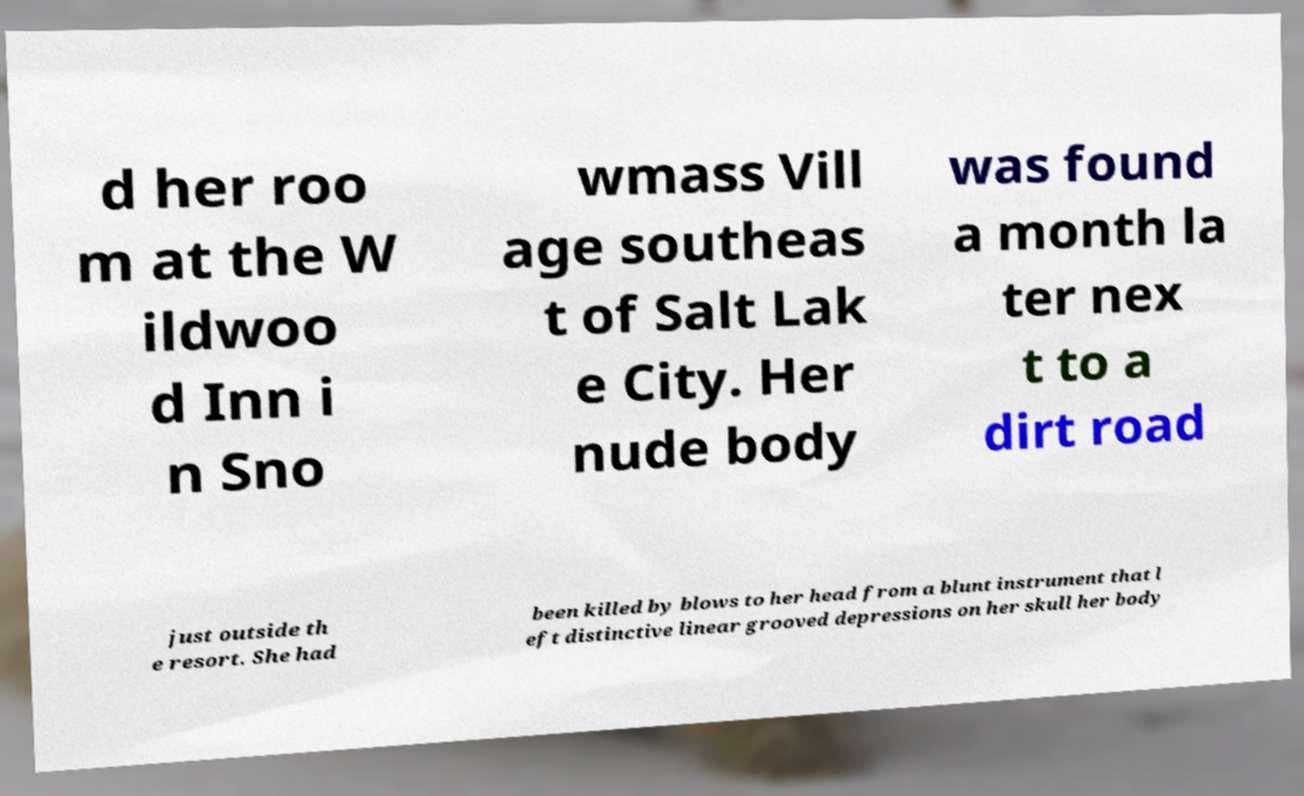Could you assist in decoding the text presented in this image and type it out clearly? d her roo m at the W ildwoo d Inn i n Sno wmass Vill age southeas t of Salt Lak e City. Her nude body was found a month la ter nex t to a dirt road just outside th e resort. She had been killed by blows to her head from a blunt instrument that l eft distinctive linear grooved depressions on her skull her body 